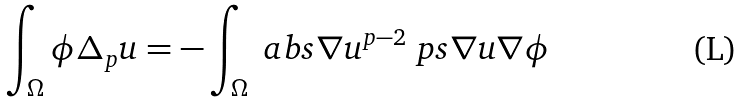Convert formula to latex. <formula><loc_0><loc_0><loc_500><loc_500>\int _ { \Omega } \phi \Delta _ { p } u = - \int _ { \Omega } \ a b s { \nabla u } ^ { p - 2 } \ p s { \nabla u } { \nabla \phi }</formula> 